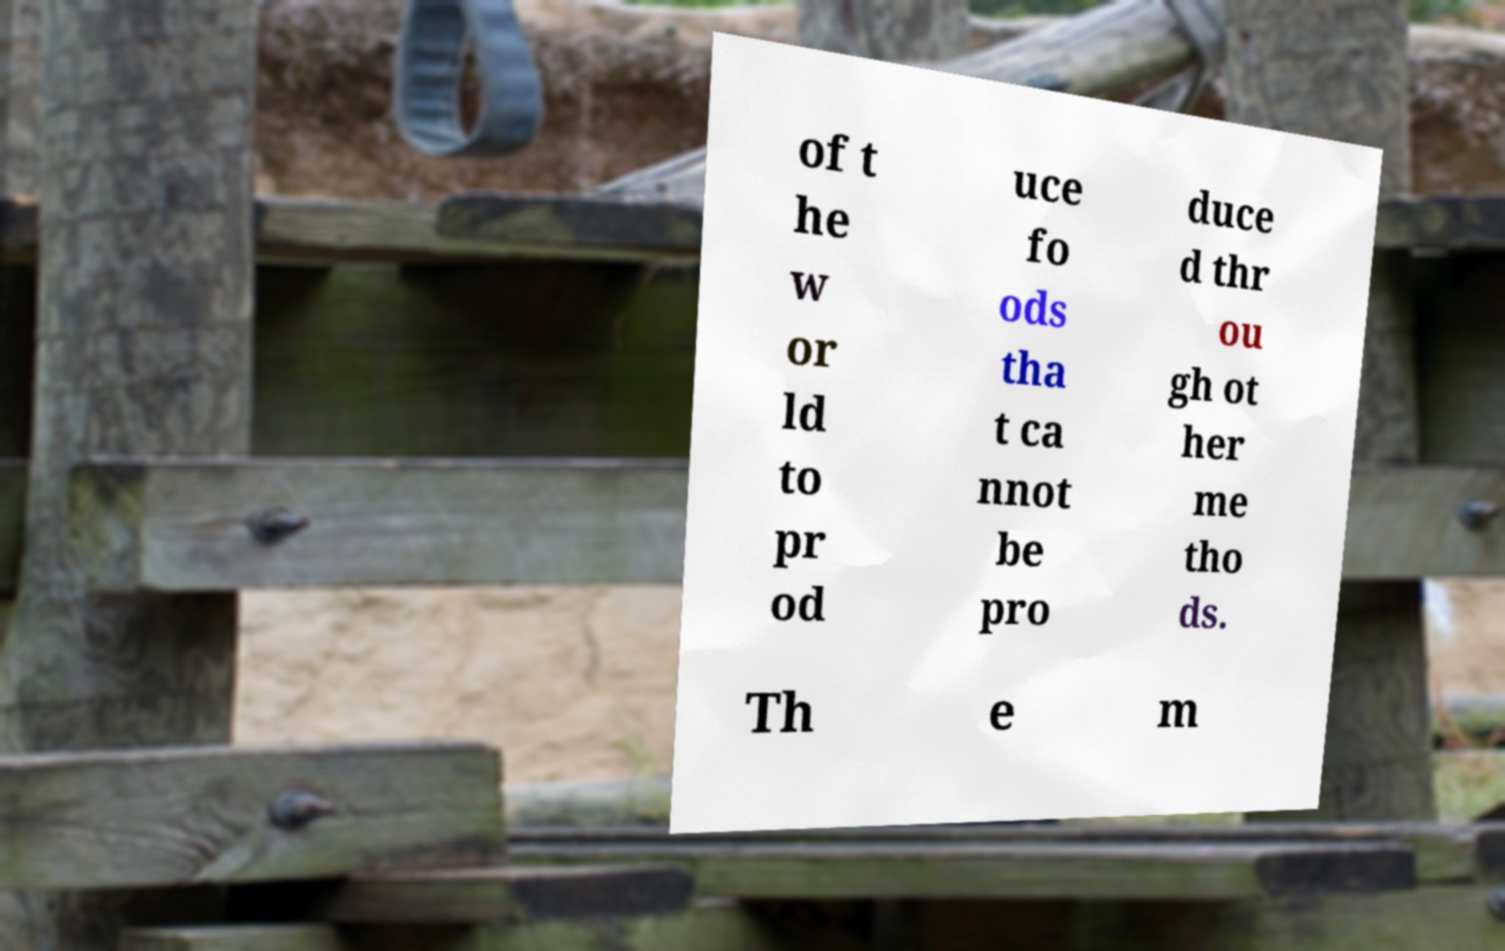Please identify and transcribe the text found in this image. of t he w or ld to pr od uce fo ods tha t ca nnot be pro duce d thr ou gh ot her me tho ds. Th e m 